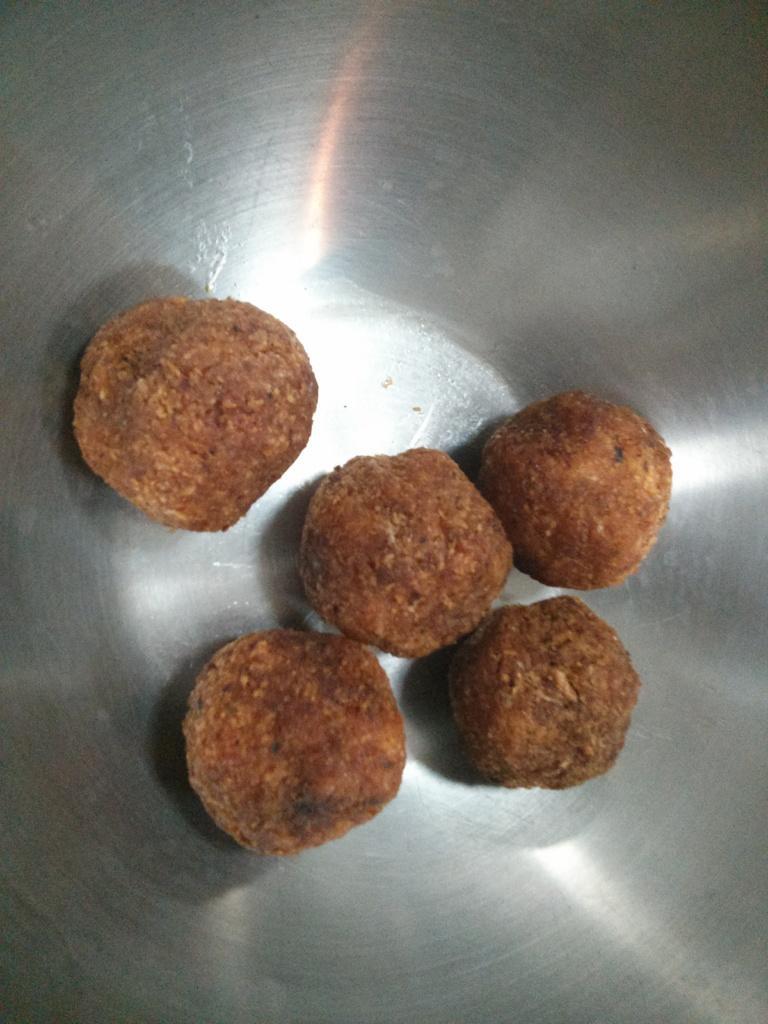Can you describe this image briefly? In the picture we can see a steel bowl and five sweets in it. 